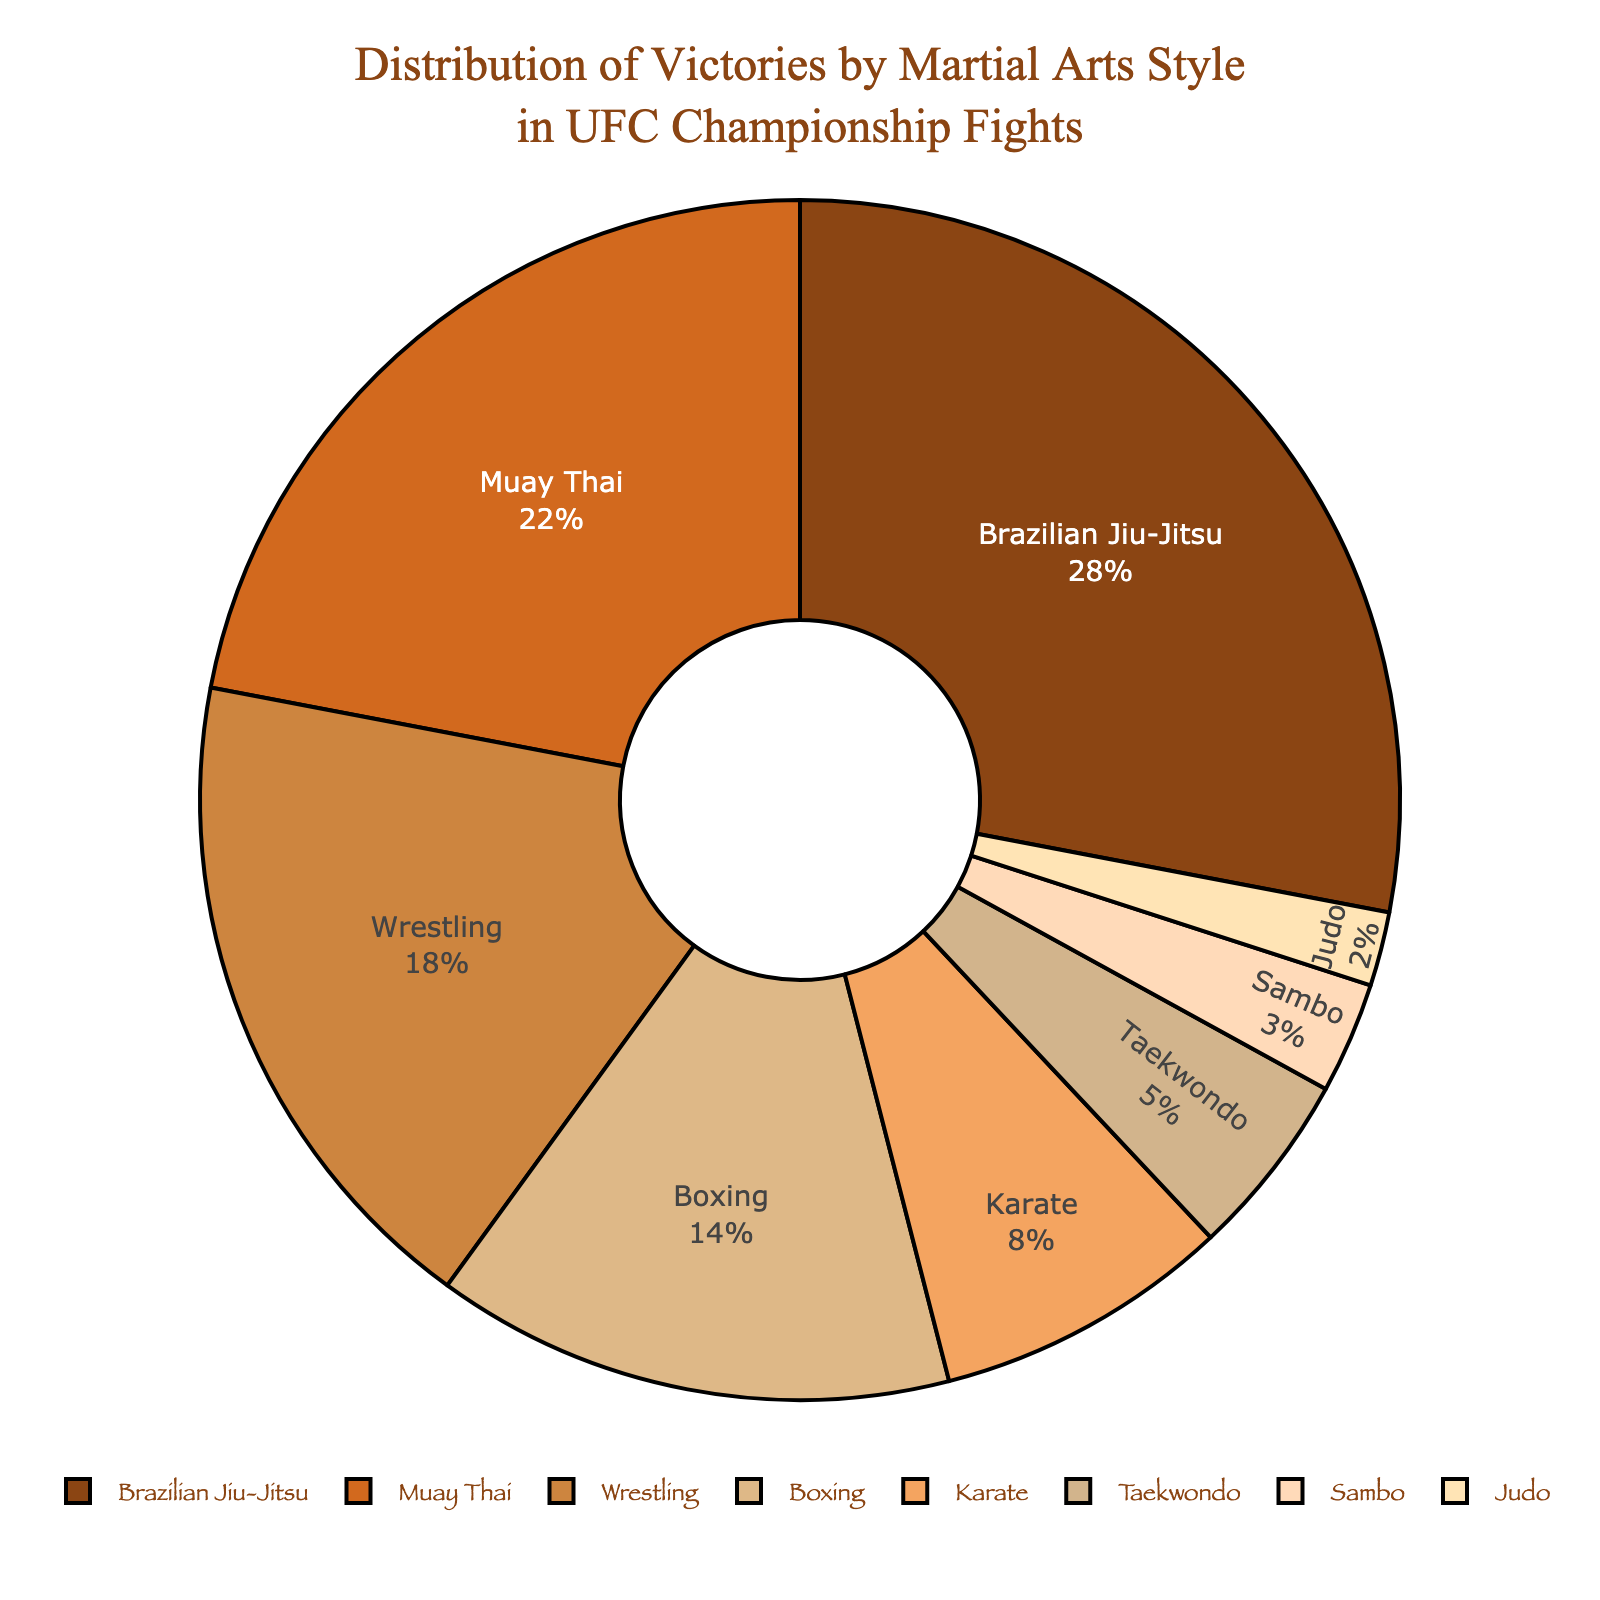Which martial arts style has the highest number of victories? The chart shows different martial arts styles and their corresponding victories. Brazilian Jiu-Jitsu has the largest pie slice, indicating it has the highest number of victories.
Answer: Brazilian Jiu-Jitsu Which two martial arts styles combined have more victories than Muay Thai? To answer, add the victories of styles with fewer victories than Muay Thai and select those whose sum exceeds 22. Boxing (14) and Karate (8) combined for 22, so including any other style will exceed Muay Thai.
Answer: Boxing and Karate How many total victories are represented in the chart? To find the total victories, sum the number of victories for each martial art: 28 (Brazilian Jiu-Jitsu) + 22 (Muay Thai) + 18 (Wrestling) + 14 (Boxing) + 8 (Karate) + 5 (Taekwondo) + 3 (Sambo) + 2 (Judo) = 100.
Answer: 100 Which martial arts style has the smallest percentage of victories? The smallest slice in the pie chart visually represents the smallest percentage. Judo, with 2 victories, has the smallest percentage.
Answer: Judo Is the number of victories in Wrestling more than both Karate and Taekwondo combined? Karate has 8 victories, and Taekwondo has 5, combining for 13. Wrestling has 18 victories, which is more than 13.
Answer: Yes Which martial arts style has nearly double the number of victories as Boxing? Boxing has 14 victories. Looking for a style with roughly double, Brazilian Jiu-Jitsu with 28 victories fits this criterion (28 is 14*2).
Answer: Brazilian Jiu-Jitsu What is the combined percentage of victories for Wrestling and Muay Thai? Wrestling has 18 wins and Muay Thai has 22. Adding these gives 40. The total victories are 100, so (40/100)*100% = 40%.
Answer: 40% How does the percentage of victories for Sambo compare to Taekwondo? Sambo has 3 victories out of 100 (so 3%), and Taekwondo has 5 out of 100 (so 5%), verifying that Sambo's percentage is less.
Answer: Less What is the difference in victories between the martial art with the most and the least victories? Brazilian Jiu-Jitsu has 28 victories, and Judo has 2. The difference is 28 - 2 = 26.
Answer: 26 Do the victories of Brazilian Jiu-Jitsu and Wrestling together surpass half of the total victories? Brazilian Jiu-Jitsu has 28 victories, and Wrestling has 18. Their combined total is 46. Half of the total victories (100) is 50. 46 does not surpass 50.
Answer: No 